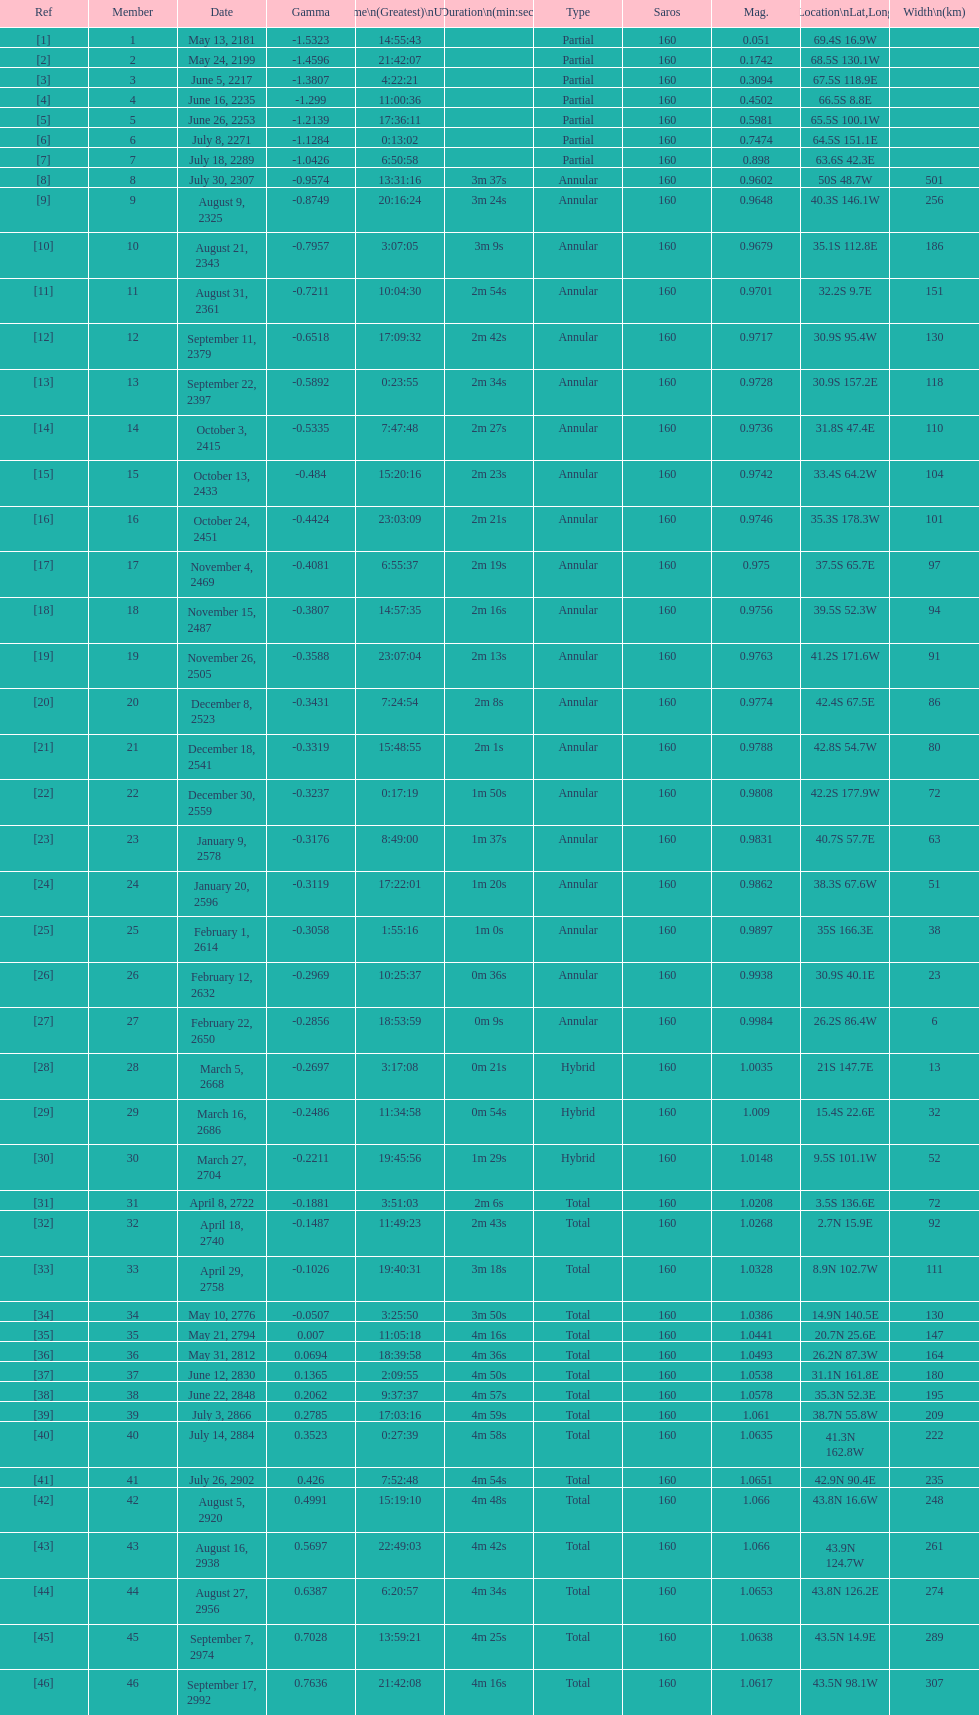What is the difference in magnitude between the may 13, 2181 solar saros and the may 24, 2199 solar saros? 0.1232. 